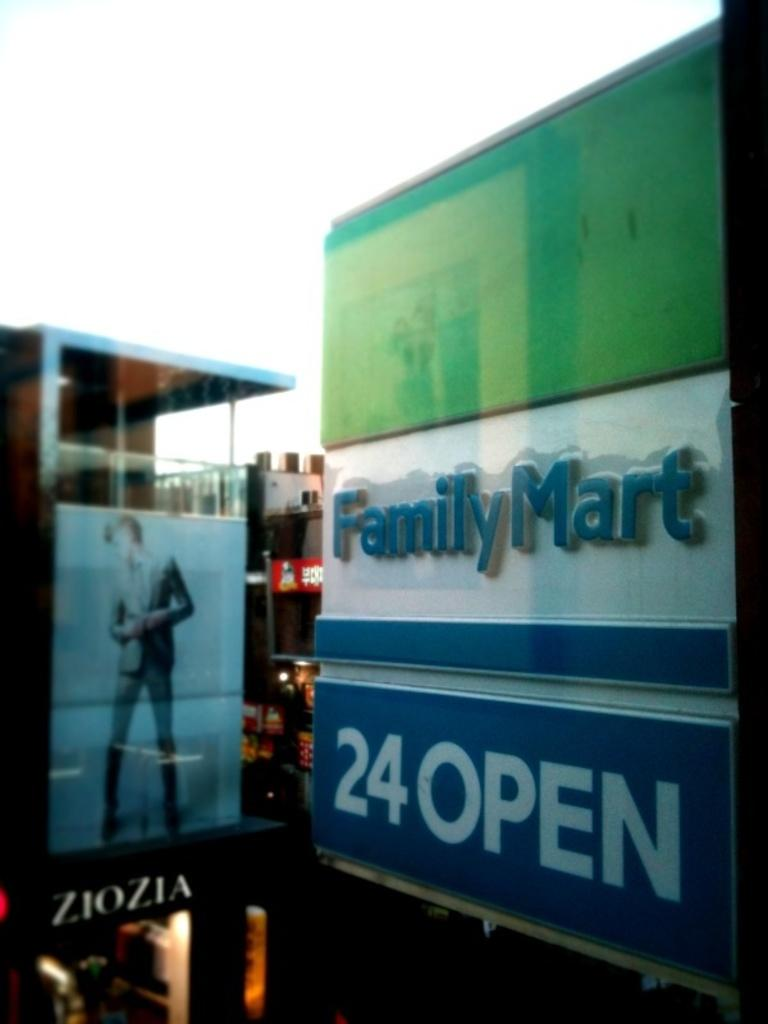<image>
Render a clear and concise summary of the photo. A store outlet sign for Family Mart which is also open 24 hours 